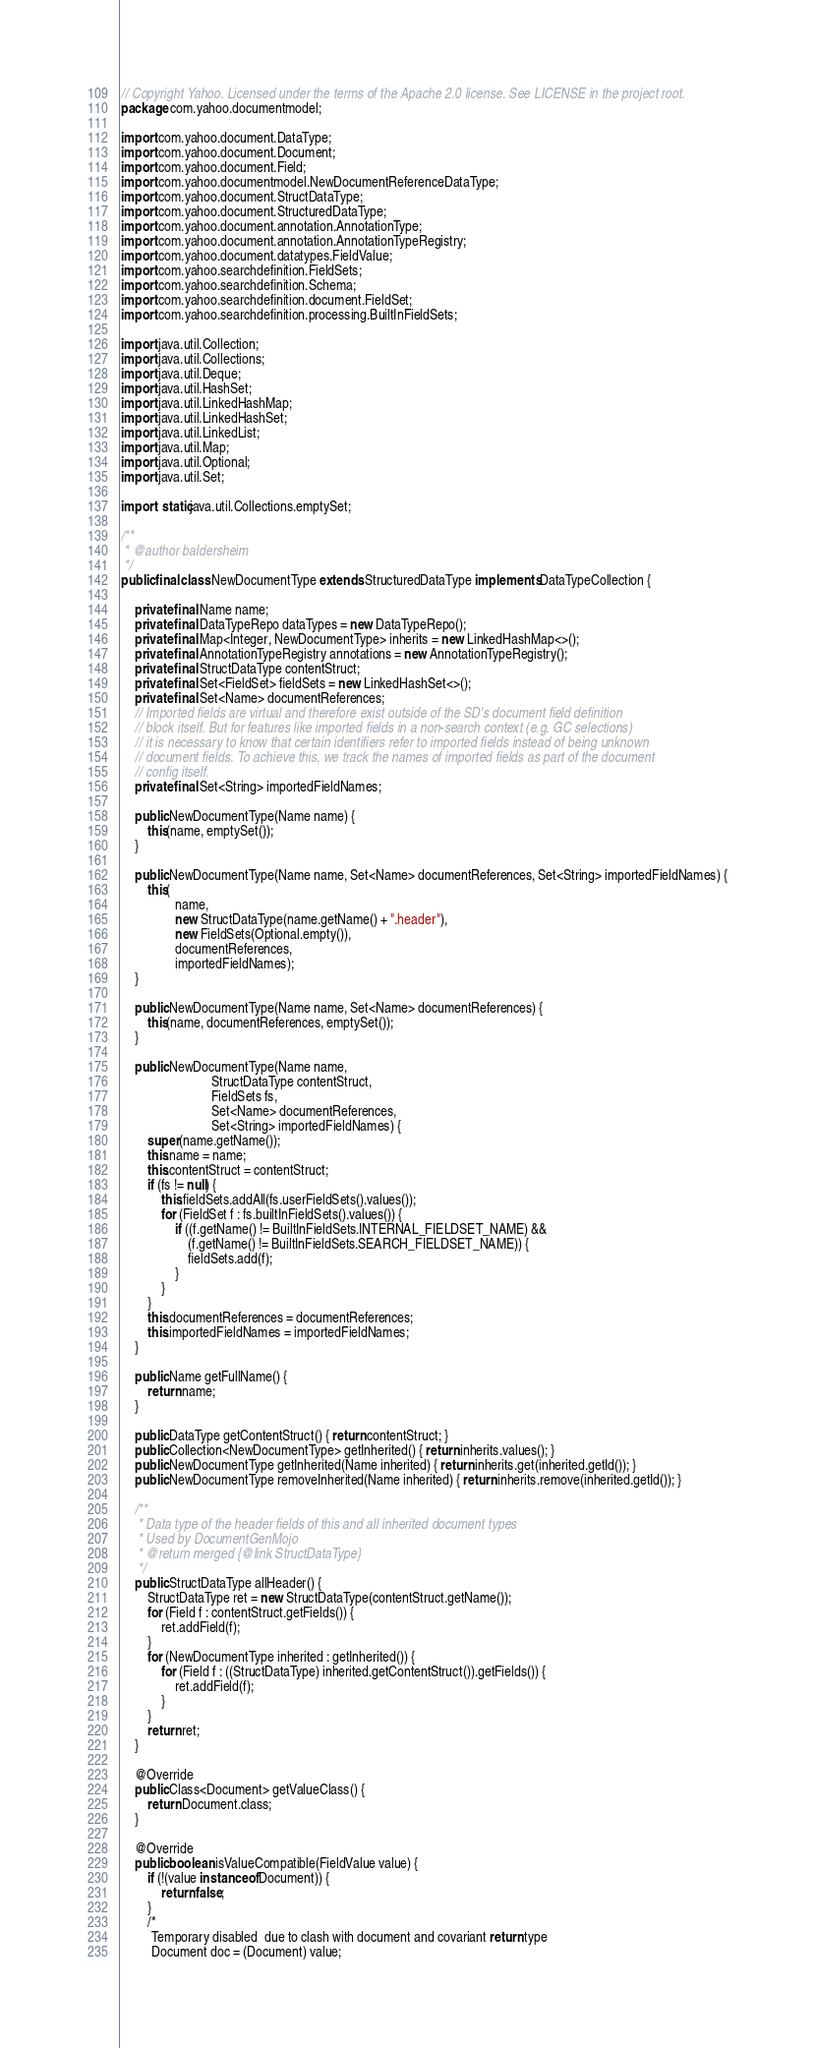Convert code to text. <code><loc_0><loc_0><loc_500><loc_500><_Java_>// Copyright Yahoo. Licensed under the terms of the Apache 2.0 license. See LICENSE in the project root.
package com.yahoo.documentmodel;

import com.yahoo.document.DataType;
import com.yahoo.document.Document;
import com.yahoo.document.Field;
import com.yahoo.documentmodel.NewDocumentReferenceDataType;
import com.yahoo.document.StructDataType;
import com.yahoo.document.StructuredDataType;
import com.yahoo.document.annotation.AnnotationType;
import com.yahoo.document.annotation.AnnotationTypeRegistry;
import com.yahoo.document.datatypes.FieldValue;
import com.yahoo.searchdefinition.FieldSets;
import com.yahoo.searchdefinition.Schema;
import com.yahoo.searchdefinition.document.FieldSet;
import com.yahoo.searchdefinition.processing.BuiltInFieldSets;

import java.util.Collection;
import java.util.Collections;
import java.util.Deque;
import java.util.HashSet;
import java.util.LinkedHashMap;
import java.util.LinkedHashSet;
import java.util.LinkedList;
import java.util.Map;
import java.util.Optional;
import java.util.Set;

import static java.util.Collections.emptySet;

/**
 * @author baldersheim
 */
public final class NewDocumentType extends StructuredDataType implements DataTypeCollection {

    private final Name name;
    private final DataTypeRepo dataTypes = new DataTypeRepo();
    private final Map<Integer, NewDocumentType> inherits = new LinkedHashMap<>();
    private final AnnotationTypeRegistry annotations = new AnnotationTypeRegistry();
    private final StructDataType contentStruct;
    private final Set<FieldSet> fieldSets = new LinkedHashSet<>();
    private final Set<Name> documentReferences;
    // Imported fields are virtual and therefore exist outside of the SD's document field definition
    // block itself. But for features like imported fields in a non-search context (e.g. GC selections)
    // it is necessary to know that certain identifiers refer to imported fields instead of being unknown
    // document fields. To achieve this, we track the names of imported fields as part of the document
    // config itself.
    private final Set<String> importedFieldNames;

    public NewDocumentType(Name name) {
        this(name, emptySet());
    }

    public NewDocumentType(Name name, Set<Name> documentReferences, Set<String> importedFieldNames) {
        this(
                name,
                new StructDataType(name.getName() + ".header"),
                new FieldSets(Optional.empty()),
                documentReferences,
                importedFieldNames);
    }

    public NewDocumentType(Name name, Set<Name> documentReferences) {
        this(name, documentReferences, emptySet());
    }

    public NewDocumentType(Name name,
                           StructDataType contentStruct,
                           FieldSets fs,
                           Set<Name> documentReferences,
                           Set<String> importedFieldNames) {
        super(name.getName());
        this.name = name;
        this.contentStruct = contentStruct;
        if (fs != null) {
            this.fieldSets.addAll(fs.userFieldSets().values());
            for (FieldSet f : fs.builtInFieldSets().values()) {
                if ((f.getName() != BuiltInFieldSets.INTERNAL_FIELDSET_NAME) &&
                    (f.getName() != BuiltInFieldSets.SEARCH_FIELDSET_NAME)) {
                    fieldSets.add(f);
                }
            }
        }
        this.documentReferences = documentReferences;
        this.importedFieldNames = importedFieldNames;
    }

    public Name getFullName() {
        return name;
    }

    public DataType getContentStruct() { return contentStruct; }
    public Collection<NewDocumentType> getInherited() { return inherits.values(); }
    public NewDocumentType getInherited(Name inherited) { return inherits.get(inherited.getId()); }
    public NewDocumentType removeInherited(Name inherited) { return inherits.remove(inherited.getId()); }

    /**
     * Data type of the header fields of this and all inherited document types
     * Used by DocumentGenMojo
     * @return merged {@link StructDataType}
     */
    public StructDataType allHeader() {
        StructDataType ret = new StructDataType(contentStruct.getName());
        for (Field f : contentStruct.getFields()) {
            ret.addField(f);
        }
        for (NewDocumentType inherited : getInherited()) {
            for (Field f : ((StructDataType) inherited.getContentStruct()).getFields()) {
                ret.addField(f);
            }
        }
        return ret;
    }

    @Override
    public Class<Document> getValueClass() {
        return Document.class;
    }

    @Override
    public boolean isValueCompatible(FieldValue value) {
        if (!(value instanceof Document)) {
            return false;
        }
        /*
         Temporary disabled  due to clash with document and covariant return type
         Document doc = (Document) value;</code> 